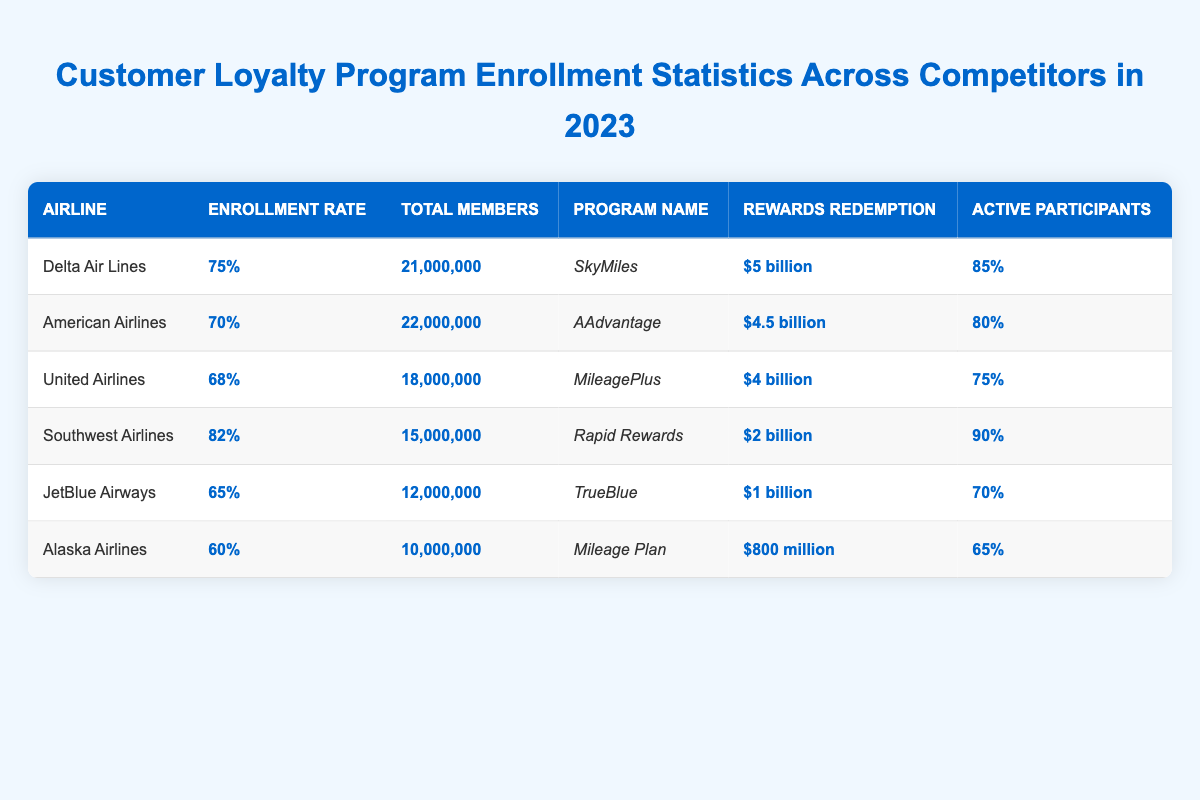What is the enrollment rate for Southwest Airlines? The table shows that Southwest Airlines has an enrollment rate of 82%.
Answer: 82% Which airline has the highest total number of members? American Airlines has the highest total members, which is 22,000,000.
Answer: 22,000,000 What is the average enrollment rate of all the airlines listed? The enrollment rates for the airlines are 75%, 70%, 68%, 82%, 65%, and 60%. To find the average, sum those rates: 75 + 70 + 68 + 82 + 65 + 60 = 420, then divide by the number of airlines (6): 420/6 = 70%.
Answer: 70% Does Delta Air Lines have a higher rewards redemption value than United Airlines? Delta Air Lines has a rewards redemption of $5 billion, while United Airlines has $4 billion. Since $5 billion is greater than $4 billion, the statement is true.
Answer: Yes What is the total rewards redemption for all airlines combined? The total rewards redemption values are $5 billion (Delta) + $4.5 billion (American) + $4 billion (United) + $2 billion (Southwest) + $1 billion (JetBlue) + $800 million (Alaska). Converting everything to billions: 5 + 4.5 + 4 + 2 + 1 + 0.8 = 17.3 billion.
Answer: $17.3 billion Which airline has the highest percentage of active participants, and what is that percentage? Looking at the values in the table, Southwest Airlines has the highest percentage of active participants at 90%.
Answer: Southwest Airlines, 90% What is the difference in total members between JetBlue Airways and Alaska Airlines? JetBlue Airways has 12,000,000 members, and Alaska Airlines has 10,000,000 members. The difference is 12,000,000 - 10,000,000 = 2,000,000.
Answer: 2,000,000 Is there an airline with an enrollment rate below 70%? JetBlue Airways (65%) and Alaska Airlines (60%) both have enrollment rates below 70%, which means the answer is yes.
Answer: Yes What is the total active participant percentage for Delta Air Lines and American Airlines combined? Delta Air Lines has 85% active participants, and American Airlines has 80%. Combining them: 85 + 80 = 165%.
Answer: 165% Which airline has the lowest rewards redemption? Alaska Airlines has the lowest rewards redemption at $800 million as shown in the table.
Answer: Alaska Airlines What percentage of total members of the airlines listed are members of Delta Air Lines? Delta Air Lines has 21,000,000 members out of a total of 21,000,000 + 22,000,000 + 18,000,000 + 15,000,000 + 12,000,000 + 10,000,000 = 98,000,000 total members. The percentage is (21,000,000 / 98,000,000) * 100 = 21.43%.
Answer: 21.43% 